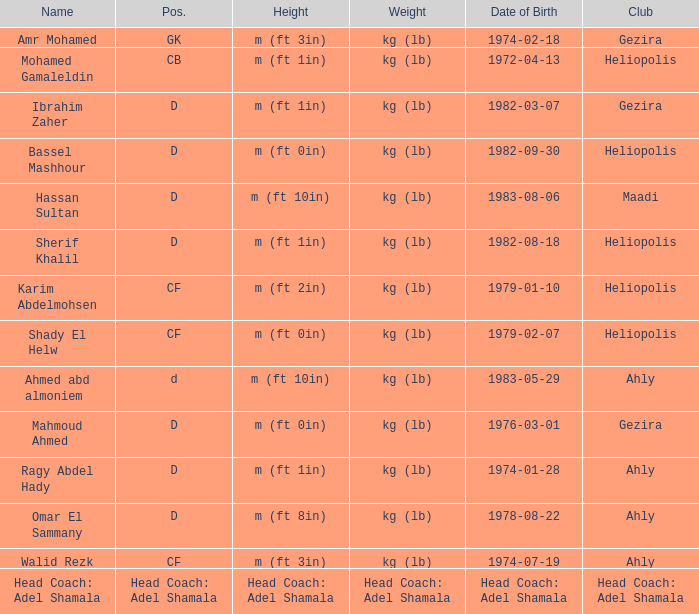What is the mass when the club is "maadi"? Kg (lb). 